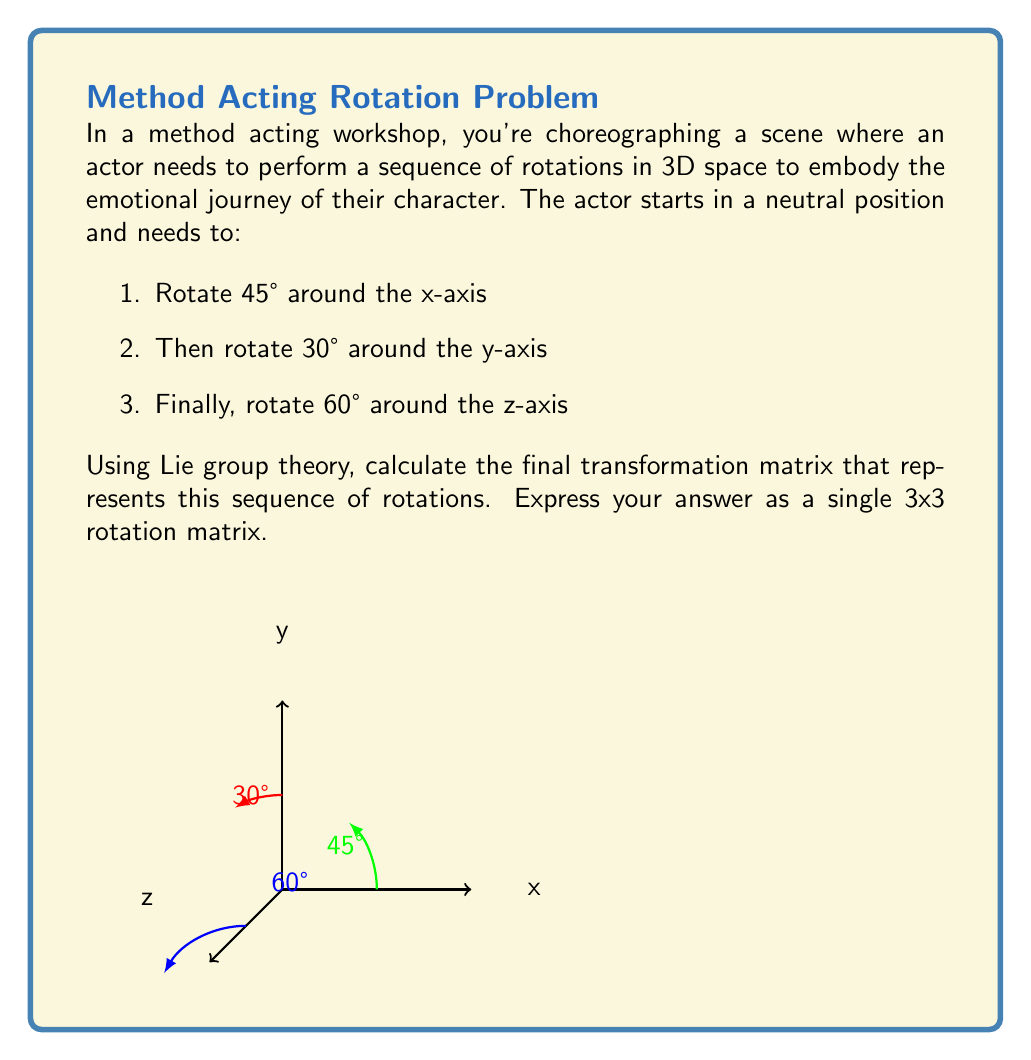Can you solve this math problem? To solve this problem, we'll use the properties of Lie groups and their corresponding Lie algebras. The sequence of rotations can be represented as a product of rotation matrices, which are elements of the SO(3) Lie group.

Step 1: Define the rotation matrices for each axis
Let's define the rotation matrices for rotations around the x, y, and z axes:

$$R_x(\theta) = \begin{pmatrix}
1 & 0 & 0 \\
0 & \cos\theta & -\sin\theta \\
0 & \sin\theta & \cos\theta
\end{pmatrix}$$

$$R_y(\theta) = \begin{pmatrix}
\cos\theta & 0 & \sin\theta \\
0 & 1 & 0 \\
-\sin\theta & 0 & \cos\theta
\end{pmatrix}$$

$$R_z(\theta) = \begin{pmatrix}
\cos\theta & -\sin\theta & 0 \\
\sin\theta & \cos\theta & 0 \\
0 & 0 & 1
\end{pmatrix}$$

Step 2: Calculate the individual rotation matrices
Now, let's calculate the rotation matrices for each step:

1. $R_x(45°) = R_x(\pi/4)$
2. $R_y(30°) = R_y(\pi/6)$
3. $R_z(60°) = R_z(\pi/3)$

Step 3: Compose the rotations
The final transformation matrix is the product of these rotations in the given order:

$$R = R_z(60°) \cdot R_y(30°) \cdot R_x(45°)$$

Step 4: Multiply the matrices
Multiplying these matrices (which can be done using a computer algebra system or by hand) gives us the final rotation matrix:

$$R = \begin{pmatrix}
\frac{\sqrt{3}}{4} & -\frac{\sqrt{3}+1}{2\sqrt{2}} & \frac{\sqrt{3}-1}{2\sqrt{2}} \\
\frac{\sqrt{3}+1}{2\sqrt{2}} & \frac{1}{4} & -\frac{\sqrt{3}}{2} \\
-\frac{\sqrt{3}-1}{2\sqrt{2}} & \frac{\sqrt{3}}{2} & \frac{1}{2}
\end{pmatrix}$$

This matrix represents the final orientation of the actor after performing the sequence of rotations.
Answer: $$R = \begin{pmatrix}
\frac{\sqrt{3}}{4} & -\frac{\sqrt{3}+1}{2\sqrt{2}} & \frac{\sqrt{3}-1}{2\sqrt{2}} \\
\frac{\sqrt{3}+1}{2\sqrt{2}} & \frac{1}{4} & -\frac{\sqrt{3}}{2} \\
-\frac{\sqrt{3}-1}{2\sqrt{2}} & \frac{\sqrt{3}}{2} & \frac{1}{2}
\end{pmatrix}$$ 